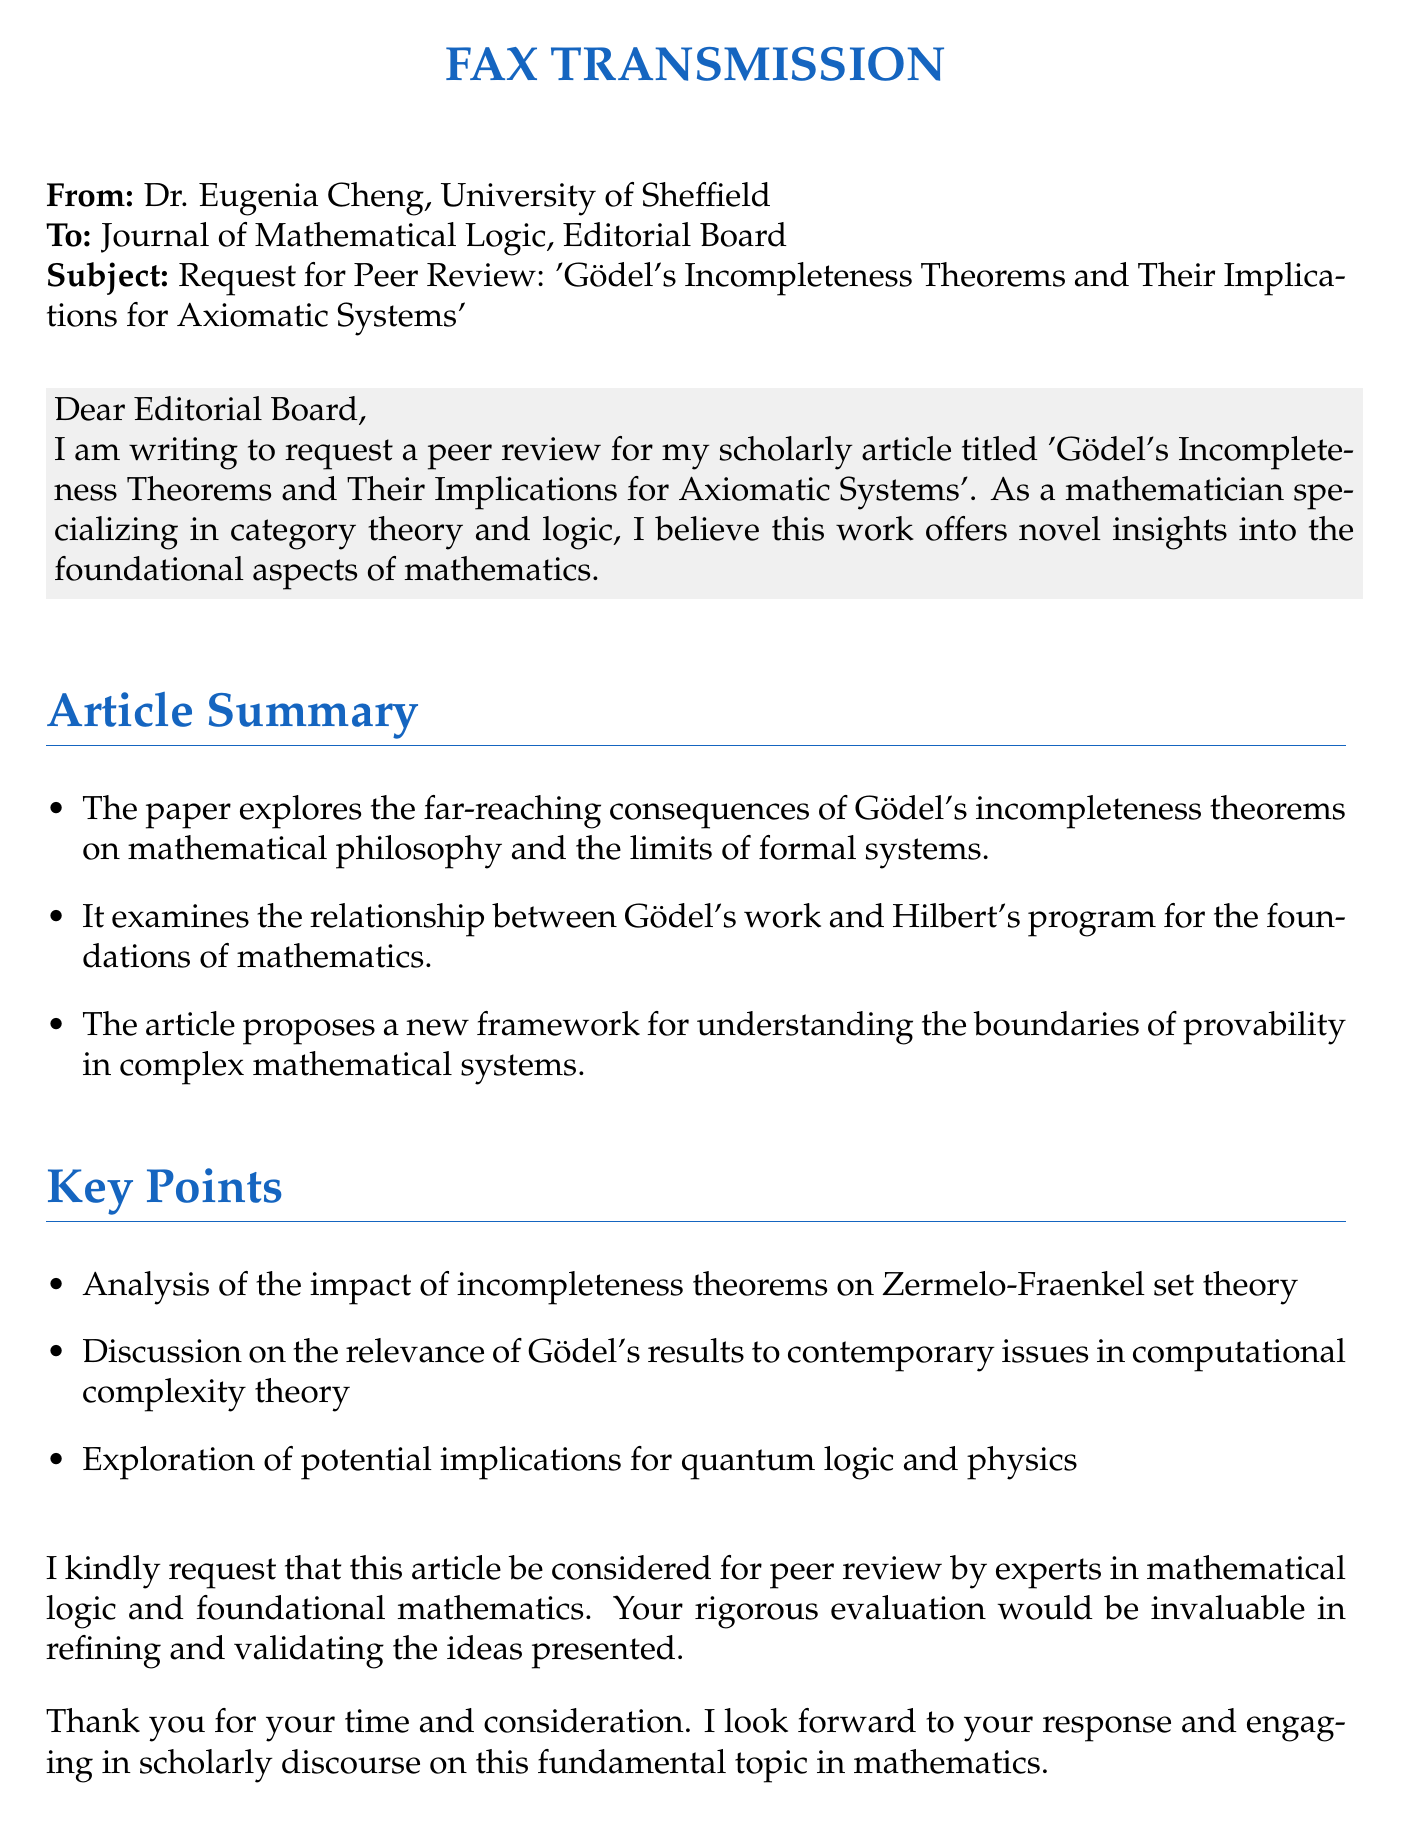What is the subject of the fax? The subject line specifies the title of the article being submitted for peer review.
Answer: Gödel's Incompleteness Theorems and Their Implications for Axiomatic Systems Who is the sender of the fax? The top of the document indicates the name of the sender, Dr. Cheng.
Answer: Dr. Eugenia Cheng What is the primary field of study of the sender? The document mentions Dr. Cheng's specialization, providing insight into her area of expertise.
Answer: Category theory and logic What does the article propose to understand? The article discusses the broader context and what it aims to address regarding mathematical systems.
Answer: The boundaries of provability in complex mathematical systems Which type of mathematical theory is discussed in relation to Gödel's theorems? The article mentions a significant mathematical theory to which Gödel's theorems are applied.
Answer: Zermelo-Fraenkel set theory What institution is Dr. Cheng affiliated with? The document provides information about Dr. Cheng’s professional affiliation.
Answer: University of Sheffield What is the primary request made in the fax? The main purpose of the document can be summarized in a single request made by Dr. Cheng to the editorial board.
Answer: Peer review How does Dr. Cheng sign off in the fax? The closing statement provides insight into Dr. Cheng's professional etiquette in communication.
Answer: Sincerely What is the contact email provided in the fax? The fax includes specific contact information for follow-up.
Answer: e.cheng@sheffield.ac.uk 